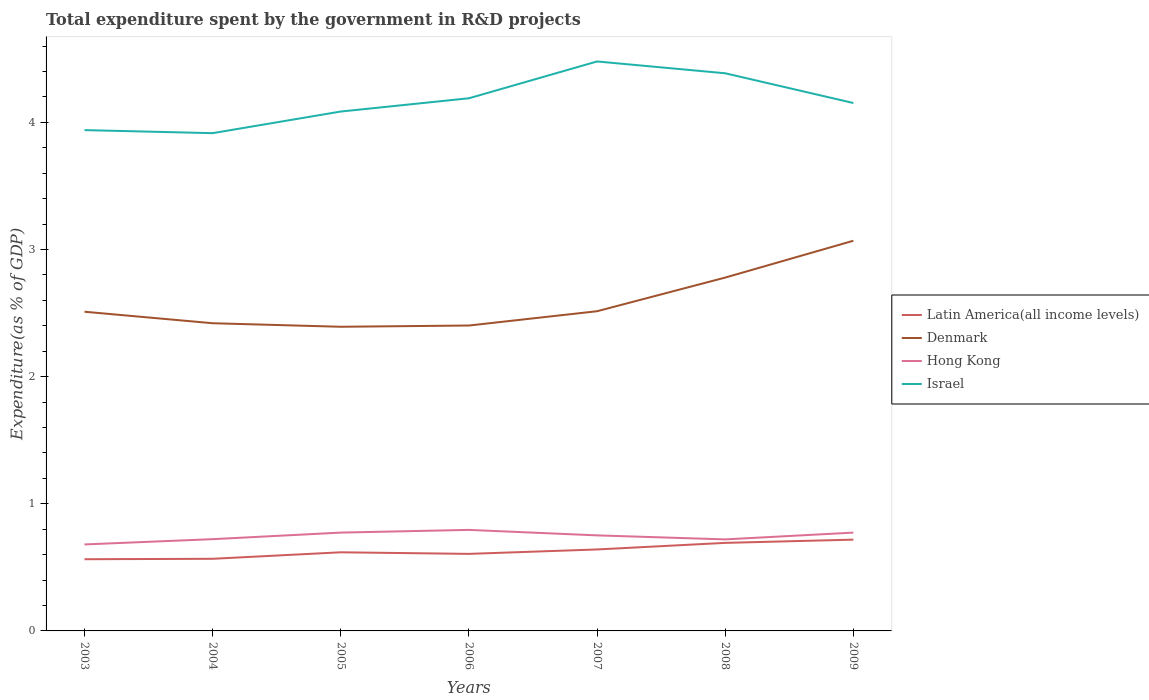How many different coloured lines are there?
Offer a very short reply. 4. Does the line corresponding to Latin America(all income levels) intersect with the line corresponding to Denmark?
Provide a short and direct response. No. Is the number of lines equal to the number of legend labels?
Give a very brief answer. Yes. Across all years, what is the maximum total expenditure spent by the government in R&D projects in Hong Kong?
Your answer should be compact. 0.68. What is the total total expenditure spent by the government in R&D projects in Israel in the graph?
Your answer should be very brief. -0.25. What is the difference between the highest and the second highest total expenditure spent by the government in R&D projects in Hong Kong?
Provide a succinct answer. 0.11. What is the difference between the highest and the lowest total expenditure spent by the government in R&D projects in Denmark?
Ensure brevity in your answer.  2. How many lines are there?
Provide a succinct answer. 4. Are the values on the major ticks of Y-axis written in scientific E-notation?
Your answer should be very brief. No. Does the graph contain any zero values?
Your response must be concise. No. Does the graph contain grids?
Your answer should be very brief. No. How many legend labels are there?
Your answer should be compact. 4. What is the title of the graph?
Offer a very short reply. Total expenditure spent by the government in R&D projects. Does "Belgium" appear as one of the legend labels in the graph?
Keep it short and to the point. No. What is the label or title of the Y-axis?
Ensure brevity in your answer.  Expenditure(as % of GDP). What is the Expenditure(as % of GDP) of Latin America(all income levels) in 2003?
Provide a succinct answer. 0.56. What is the Expenditure(as % of GDP) of Denmark in 2003?
Offer a terse response. 2.51. What is the Expenditure(as % of GDP) in Hong Kong in 2003?
Your answer should be very brief. 0.68. What is the Expenditure(as % of GDP) in Israel in 2003?
Ensure brevity in your answer.  3.94. What is the Expenditure(as % of GDP) in Latin America(all income levels) in 2004?
Offer a terse response. 0.57. What is the Expenditure(as % of GDP) in Denmark in 2004?
Make the answer very short. 2.42. What is the Expenditure(as % of GDP) in Hong Kong in 2004?
Offer a terse response. 0.72. What is the Expenditure(as % of GDP) of Israel in 2004?
Offer a terse response. 3.92. What is the Expenditure(as % of GDP) of Latin America(all income levels) in 2005?
Your answer should be compact. 0.62. What is the Expenditure(as % of GDP) of Denmark in 2005?
Provide a short and direct response. 2.39. What is the Expenditure(as % of GDP) in Hong Kong in 2005?
Your answer should be very brief. 0.77. What is the Expenditure(as % of GDP) in Israel in 2005?
Offer a very short reply. 4.09. What is the Expenditure(as % of GDP) of Latin America(all income levels) in 2006?
Provide a succinct answer. 0.61. What is the Expenditure(as % of GDP) of Denmark in 2006?
Ensure brevity in your answer.  2.4. What is the Expenditure(as % of GDP) in Hong Kong in 2006?
Keep it short and to the point. 0.79. What is the Expenditure(as % of GDP) of Israel in 2006?
Ensure brevity in your answer.  4.19. What is the Expenditure(as % of GDP) in Latin America(all income levels) in 2007?
Your answer should be very brief. 0.64. What is the Expenditure(as % of GDP) of Denmark in 2007?
Offer a very short reply. 2.51. What is the Expenditure(as % of GDP) in Hong Kong in 2007?
Provide a succinct answer. 0.75. What is the Expenditure(as % of GDP) in Israel in 2007?
Provide a succinct answer. 4.48. What is the Expenditure(as % of GDP) of Latin America(all income levels) in 2008?
Give a very brief answer. 0.69. What is the Expenditure(as % of GDP) in Denmark in 2008?
Offer a terse response. 2.78. What is the Expenditure(as % of GDP) of Hong Kong in 2008?
Keep it short and to the point. 0.72. What is the Expenditure(as % of GDP) in Israel in 2008?
Your answer should be compact. 4.39. What is the Expenditure(as % of GDP) in Latin America(all income levels) in 2009?
Make the answer very short. 0.72. What is the Expenditure(as % of GDP) in Denmark in 2009?
Ensure brevity in your answer.  3.07. What is the Expenditure(as % of GDP) in Hong Kong in 2009?
Offer a terse response. 0.77. What is the Expenditure(as % of GDP) of Israel in 2009?
Provide a succinct answer. 4.15. Across all years, what is the maximum Expenditure(as % of GDP) of Latin America(all income levels)?
Provide a succinct answer. 0.72. Across all years, what is the maximum Expenditure(as % of GDP) in Denmark?
Give a very brief answer. 3.07. Across all years, what is the maximum Expenditure(as % of GDP) of Hong Kong?
Ensure brevity in your answer.  0.79. Across all years, what is the maximum Expenditure(as % of GDP) of Israel?
Offer a very short reply. 4.48. Across all years, what is the minimum Expenditure(as % of GDP) in Latin America(all income levels)?
Your answer should be very brief. 0.56. Across all years, what is the minimum Expenditure(as % of GDP) in Denmark?
Your response must be concise. 2.39. Across all years, what is the minimum Expenditure(as % of GDP) in Hong Kong?
Ensure brevity in your answer.  0.68. Across all years, what is the minimum Expenditure(as % of GDP) of Israel?
Provide a short and direct response. 3.92. What is the total Expenditure(as % of GDP) in Latin America(all income levels) in the graph?
Give a very brief answer. 4.41. What is the total Expenditure(as % of GDP) of Denmark in the graph?
Your response must be concise. 18.09. What is the total Expenditure(as % of GDP) of Hong Kong in the graph?
Provide a succinct answer. 5.22. What is the total Expenditure(as % of GDP) in Israel in the graph?
Offer a terse response. 29.15. What is the difference between the Expenditure(as % of GDP) of Latin America(all income levels) in 2003 and that in 2004?
Keep it short and to the point. -0. What is the difference between the Expenditure(as % of GDP) of Denmark in 2003 and that in 2004?
Your answer should be compact. 0.09. What is the difference between the Expenditure(as % of GDP) of Hong Kong in 2003 and that in 2004?
Make the answer very short. -0.04. What is the difference between the Expenditure(as % of GDP) of Israel in 2003 and that in 2004?
Provide a short and direct response. 0.02. What is the difference between the Expenditure(as % of GDP) of Latin America(all income levels) in 2003 and that in 2005?
Offer a very short reply. -0.05. What is the difference between the Expenditure(as % of GDP) in Denmark in 2003 and that in 2005?
Your answer should be compact. 0.12. What is the difference between the Expenditure(as % of GDP) in Hong Kong in 2003 and that in 2005?
Your response must be concise. -0.09. What is the difference between the Expenditure(as % of GDP) of Israel in 2003 and that in 2005?
Your answer should be compact. -0.15. What is the difference between the Expenditure(as % of GDP) in Latin America(all income levels) in 2003 and that in 2006?
Offer a terse response. -0.04. What is the difference between the Expenditure(as % of GDP) of Denmark in 2003 and that in 2006?
Provide a short and direct response. 0.11. What is the difference between the Expenditure(as % of GDP) of Hong Kong in 2003 and that in 2006?
Keep it short and to the point. -0.11. What is the difference between the Expenditure(as % of GDP) in Israel in 2003 and that in 2006?
Provide a short and direct response. -0.25. What is the difference between the Expenditure(as % of GDP) of Latin America(all income levels) in 2003 and that in 2007?
Provide a short and direct response. -0.08. What is the difference between the Expenditure(as % of GDP) of Denmark in 2003 and that in 2007?
Your response must be concise. -0. What is the difference between the Expenditure(as % of GDP) of Hong Kong in 2003 and that in 2007?
Ensure brevity in your answer.  -0.07. What is the difference between the Expenditure(as % of GDP) of Israel in 2003 and that in 2007?
Give a very brief answer. -0.54. What is the difference between the Expenditure(as % of GDP) of Latin America(all income levels) in 2003 and that in 2008?
Offer a terse response. -0.13. What is the difference between the Expenditure(as % of GDP) of Denmark in 2003 and that in 2008?
Provide a short and direct response. -0.27. What is the difference between the Expenditure(as % of GDP) in Hong Kong in 2003 and that in 2008?
Make the answer very short. -0.04. What is the difference between the Expenditure(as % of GDP) of Israel in 2003 and that in 2008?
Offer a very short reply. -0.45. What is the difference between the Expenditure(as % of GDP) in Latin America(all income levels) in 2003 and that in 2009?
Offer a terse response. -0.15. What is the difference between the Expenditure(as % of GDP) of Denmark in 2003 and that in 2009?
Make the answer very short. -0.56. What is the difference between the Expenditure(as % of GDP) of Hong Kong in 2003 and that in 2009?
Ensure brevity in your answer.  -0.09. What is the difference between the Expenditure(as % of GDP) of Israel in 2003 and that in 2009?
Provide a succinct answer. -0.21. What is the difference between the Expenditure(as % of GDP) of Latin America(all income levels) in 2004 and that in 2005?
Make the answer very short. -0.05. What is the difference between the Expenditure(as % of GDP) of Denmark in 2004 and that in 2005?
Ensure brevity in your answer.  0.03. What is the difference between the Expenditure(as % of GDP) in Hong Kong in 2004 and that in 2005?
Give a very brief answer. -0.05. What is the difference between the Expenditure(as % of GDP) in Israel in 2004 and that in 2005?
Offer a terse response. -0.17. What is the difference between the Expenditure(as % of GDP) of Latin America(all income levels) in 2004 and that in 2006?
Offer a very short reply. -0.04. What is the difference between the Expenditure(as % of GDP) of Denmark in 2004 and that in 2006?
Offer a very short reply. 0.02. What is the difference between the Expenditure(as % of GDP) in Hong Kong in 2004 and that in 2006?
Make the answer very short. -0.07. What is the difference between the Expenditure(as % of GDP) in Israel in 2004 and that in 2006?
Provide a short and direct response. -0.27. What is the difference between the Expenditure(as % of GDP) of Latin America(all income levels) in 2004 and that in 2007?
Keep it short and to the point. -0.07. What is the difference between the Expenditure(as % of GDP) of Denmark in 2004 and that in 2007?
Provide a succinct answer. -0.09. What is the difference between the Expenditure(as % of GDP) in Hong Kong in 2004 and that in 2007?
Make the answer very short. -0.03. What is the difference between the Expenditure(as % of GDP) in Israel in 2004 and that in 2007?
Your answer should be very brief. -0.56. What is the difference between the Expenditure(as % of GDP) in Latin America(all income levels) in 2004 and that in 2008?
Provide a succinct answer. -0.13. What is the difference between the Expenditure(as % of GDP) in Denmark in 2004 and that in 2008?
Keep it short and to the point. -0.36. What is the difference between the Expenditure(as % of GDP) in Hong Kong in 2004 and that in 2008?
Ensure brevity in your answer.  0. What is the difference between the Expenditure(as % of GDP) in Israel in 2004 and that in 2008?
Your answer should be compact. -0.47. What is the difference between the Expenditure(as % of GDP) in Latin America(all income levels) in 2004 and that in 2009?
Make the answer very short. -0.15. What is the difference between the Expenditure(as % of GDP) of Denmark in 2004 and that in 2009?
Keep it short and to the point. -0.65. What is the difference between the Expenditure(as % of GDP) of Hong Kong in 2004 and that in 2009?
Offer a very short reply. -0.05. What is the difference between the Expenditure(as % of GDP) of Israel in 2004 and that in 2009?
Keep it short and to the point. -0.24. What is the difference between the Expenditure(as % of GDP) of Latin America(all income levels) in 2005 and that in 2006?
Ensure brevity in your answer.  0.01. What is the difference between the Expenditure(as % of GDP) in Denmark in 2005 and that in 2006?
Your response must be concise. -0.01. What is the difference between the Expenditure(as % of GDP) of Hong Kong in 2005 and that in 2006?
Give a very brief answer. -0.02. What is the difference between the Expenditure(as % of GDP) of Israel in 2005 and that in 2006?
Offer a very short reply. -0.1. What is the difference between the Expenditure(as % of GDP) in Latin America(all income levels) in 2005 and that in 2007?
Your answer should be very brief. -0.02. What is the difference between the Expenditure(as % of GDP) in Denmark in 2005 and that in 2007?
Your response must be concise. -0.12. What is the difference between the Expenditure(as % of GDP) of Hong Kong in 2005 and that in 2007?
Your answer should be very brief. 0.02. What is the difference between the Expenditure(as % of GDP) of Israel in 2005 and that in 2007?
Give a very brief answer. -0.39. What is the difference between the Expenditure(as % of GDP) in Latin America(all income levels) in 2005 and that in 2008?
Your answer should be very brief. -0.07. What is the difference between the Expenditure(as % of GDP) of Denmark in 2005 and that in 2008?
Your answer should be compact. -0.39. What is the difference between the Expenditure(as % of GDP) in Hong Kong in 2005 and that in 2008?
Your answer should be compact. 0.05. What is the difference between the Expenditure(as % of GDP) of Israel in 2005 and that in 2008?
Offer a very short reply. -0.3. What is the difference between the Expenditure(as % of GDP) of Latin America(all income levels) in 2005 and that in 2009?
Give a very brief answer. -0.1. What is the difference between the Expenditure(as % of GDP) in Denmark in 2005 and that in 2009?
Your answer should be very brief. -0.68. What is the difference between the Expenditure(as % of GDP) of Hong Kong in 2005 and that in 2009?
Your answer should be compact. 0. What is the difference between the Expenditure(as % of GDP) of Israel in 2005 and that in 2009?
Offer a very short reply. -0.07. What is the difference between the Expenditure(as % of GDP) in Latin America(all income levels) in 2006 and that in 2007?
Keep it short and to the point. -0.03. What is the difference between the Expenditure(as % of GDP) in Denmark in 2006 and that in 2007?
Ensure brevity in your answer.  -0.11. What is the difference between the Expenditure(as % of GDP) in Hong Kong in 2006 and that in 2007?
Ensure brevity in your answer.  0.04. What is the difference between the Expenditure(as % of GDP) in Israel in 2006 and that in 2007?
Keep it short and to the point. -0.29. What is the difference between the Expenditure(as % of GDP) of Latin America(all income levels) in 2006 and that in 2008?
Make the answer very short. -0.09. What is the difference between the Expenditure(as % of GDP) in Denmark in 2006 and that in 2008?
Provide a succinct answer. -0.38. What is the difference between the Expenditure(as % of GDP) of Hong Kong in 2006 and that in 2008?
Offer a very short reply. 0.07. What is the difference between the Expenditure(as % of GDP) in Israel in 2006 and that in 2008?
Make the answer very short. -0.2. What is the difference between the Expenditure(as % of GDP) in Latin America(all income levels) in 2006 and that in 2009?
Provide a succinct answer. -0.11. What is the difference between the Expenditure(as % of GDP) in Denmark in 2006 and that in 2009?
Provide a short and direct response. -0.67. What is the difference between the Expenditure(as % of GDP) in Hong Kong in 2006 and that in 2009?
Your response must be concise. 0.02. What is the difference between the Expenditure(as % of GDP) in Israel in 2006 and that in 2009?
Provide a short and direct response. 0.04. What is the difference between the Expenditure(as % of GDP) of Latin America(all income levels) in 2007 and that in 2008?
Make the answer very short. -0.05. What is the difference between the Expenditure(as % of GDP) in Denmark in 2007 and that in 2008?
Make the answer very short. -0.26. What is the difference between the Expenditure(as % of GDP) of Hong Kong in 2007 and that in 2008?
Provide a succinct answer. 0.03. What is the difference between the Expenditure(as % of GDP) of Israel in 2007 and that in 2008?
Provide a succinct answer. 0.09. What is the difference between the Expenditure(as % of GDP) in Latin America(all income levels) in 2007 and that in 2009?
Your response must be concise. -0.08. What is the difference between the Expenditure(as % of GDP) in Denmark in 2007 and that in 2009?
Your answer should be very brief. -0.55. What is the difference between the Expenditure(as % of GDP) of Hong Kong in 2007 and that in 2009?
Offer a very short reply. -0.02. What is the difference between the Expenditure(as % of GDP) in Israel in 2007 and that in 2009?
Your answer should be very brief. 0.33. What is the difference between the Expenditure(as % of GDP) in Latin America(all income levels) in 2008 and that in 2009?
Make the answer very short. -0.03. What is the difference between the Expenditure(as % of GDP) of Denmark in 2008 and that in 2009?
Offer a very short reply. -0.29. What is the difference between the Expenditure(as % of GDP) of Hong Kong in 2008 and that in 2009?
Offer a terse response. -0.05. What is the difference between the Expenditure(as % of GDP) in Israel in 2008 and that in 2009?
Ensure brevity in your answer.  0.23. What is the difference between the Expenditure(as % of GDP) in Latin America(all income levels) in 2003 and the Expenditure(as % of GDP) in Denmark in 2004?
Provide a succinct answer. -1.86. What is the difference between the Expenditure(as % of GDP) in Latin America(all income levels) in 2003 and the Expenditure(as % of GDP) in Hong Kong in 2004?
Keep it short and to the point. -0.16. What is the difference between the Expenditure(as % of GDP) of Latin America(all income levels) in 2003 and the Expenditure(as % of GDP) of Israel in 2004?
Ensure brevity in your answer.  -3.35. What is the difference between the Expenditure(as % of GDP) in Denmark in 2003 and the Expenditure(as % of GDP) in Hong Kong in 2004?
Provide a succinct answer. 1.79. What is the difference between the Expenditure(as % of GDP) in Denmark in 2003 and the Expenditure(as % of GDP) in Israel in 2004?
Your answer should be compact. -1.4. What is the difference between the Expenditure(as % of GDP) of Hong Kong in 2003 and the Expenditure(as % of GDP) of Israel in 2004?
Offer a terse response. -3.24. What is the difference between the Expenditure(as % of GDP) in Latin America(all income levels) in 2003 and the Expenditure(as % of GDP) in Denmark in 2005?
Provide a short and direct response. -1.83. What is the difference between the Expenditure(as % of GDP) of Latin America(all income levels) in 2003 and the Expenditure(as % of GDP) of Hong Kong in 2005?
Provide a succinct answer. -0.21. What is the difference between the Expenditure(as % of GDP) in Latin America(all income levels) in 2003 and the Expenditure(as % of GDP) in Israel in 2005?
Your response must be concise. -3.52. What is the difference between the Expenditure(as % of GDP) in Denmark in 2003 and the Expenditure(as % of GDP) in Hong Kong in 2005?
Offer a terse response. 1.74. What is the difference between the Expenditure(as % of GDP) in Denmark in 2003 and the Expenditure(as % of GDP) in Israel in 2005?
Your answer should be very brief. -1.57. What is the difference between the Expenditure(as % of GDP) in Hong Kong in 2003 and the Expenditure(as % of GDP) in Israel in 2005?
Your answer should be very brief. -3.41. What is the difference between the Expenditure(as % of GDP) in Latin America(all income levels) in 2003 and the Expenditure(as % of GDP) in Denmark in 2006?
Offer a very short reply. -1.84. What is the difference between the Expenditure(as % of GDP) of Latin America(all income levels) in 2003 and the Expenditure(as % of GDP) of Hong Kong in 2006?
Provide a short and direct response. -0.23. What is the difference between the Expenditure(as % of GDP) of Latin America(all income levels) in 2003 and the Expenditure(as % of GDP) of Israel in 2006?
Your response must be concise. -3.63. What is the difference between the Expenditure(as % of GDP) of Denmark in 2003 and the Expenditure(as % of GDP) of Hong Kong in 2006?
Your response must be concise. 1.72. What is the difference between the Expenditure(as % of GDP) in Denmark in 2003 and the Expenditure(as % of GDP) in Israel in 2006?
Offer a very short reply. -1.68. What is the difference between the Expenditure(as % of GDP) in Hong Kong in 2003 and the Expenditure(as % of GDP) in Israel in 2006?
Your response must be concise. -3.51. What is the difference between the Expenditure(as % of GDP) in Latin America(all income levels) in 2003 and the Expenditure(as % of GDP) in Denmark in 2007?
Ensure brevity in your answer.  -1.95. What is the difference between the Expenditure(as % of GDP) of Latin America(all income levels) in 2003 and the Expenditure(as % of GDP) of Hong Kong in 2007?
Ensure brevity in your answer.  -0.19. What is the difference between the Expenditure(as % of GDP) of Latin America(all income levels) in 2003 and the Expenditure(as % of GDP) of Israel in 2007?
Provide a succinct answer. -3.92. What is the difference between the Expenditure(as % of GDP) of Denmark in 2003 and the Expenditure(as % of GDP) of Hong Kong in 2007?
Make the answer very short. 1.76. What is the difference between the Expenditure(as % of GDP) of Denmark in 2003 and the Expenditure(as % of GDP) of Israel in 2007?
Ensure brevity in your answer.  -1.97. What is the difference between the Expenditure(as % of GDP) in Hong Kong in 2003 and the Expenditure(as % of GDP) in Israel in 2007?
Ensure brevity in your answer.  -3.8. What is the difference between the Expenditure(as % of GDP) in Latin America(all income levels) in 2003 and the Expenditure(as % of GDP) in Denmark in 2008?
Your response must be concise. -2.22. What is the difference between the Expenditure(as % of GDP) in Latin America(all income levels) in 2003 and the Expenditure(as % of GDP) in Hong Kong in 2008?
Your answer should be compact. -0.16. What is the difference between the Expenditure(as % of GDP) of Latin America(all income levels) in 2003 and the Expenditure(as % of GDP) of Israel in 2008?
Ensure brevity in your answer.  -3.82. What is the difference between the Expenditure(as % of GDP) in Denmark in 2003 and the Expenditure(as % of GDP) in Hong Kong in 2008?
Keep it short and to the point. 1.79. What is the difference between the Expenditure(as % of GDP) of Denmark in 2003 and the Expenditure(as % of GDP) of Israel in 2008?
Provide a succinct answer. -1.88. What is the difference between the Expenditure(as % of GDP) of Hong Kong in 2003 and the Expenditure(as % of GDP) of Israel in 2008?
Ensure brevity in your answer.  -3.71. What is the difference between the Expenditure(as % of GDP) in Latin America(all income levels) in 2003 and the Expenditure(as % of GDP) in Denmark in 2009?
Give a very brief answer. -2.51. What is the difference between the Expenditure(as % of GDP) in Latin America(all income levels) in 2003 and the Expenditure(as % of GDP) in Hong Kong in 2009?
Keep it short and to the point. -0.21. What is the difference between the Expenditure(as % of GDP) in Latin America(all income levels) in 2003 and the Expenditure(as % of GDP) in Israel in 2009?
Give a very brief answer. -3.59. What is the difference between the Expenditure(as % of GDP) of Denmark in 2003 and the Expenditure(as % of GDP) of Hong Kong in 2009?
Provide a short and direct response. 1.74. What is the difference between the Expenditure(as % of GDP) in Denmark in 2003 and the Expenditure(as % of GDP) in Israel in 2009?
Provide a short and direct response. -1.64. What is the difference between the Expenditure(as % of GDP) in Hong Kong in 2003 and the Expenditure(as % of GDP) in Israel in 2009?
Provide a succinct answer. -3.47. What is the difference between the Expenditure(as % of GDP) in Latin America(all income levels) in 2004 and the Expenditure(as % of GDP) in Denmark in 2005?
Make the answer very short. -1.83. What is the difference between the Expenditure(as % of GDP) in Latin America(all income levels) in 2004 and the Expenditure(as % of GDP) in Hong Kong in 2005?
Provide a succinct answer. -0.21. What is the difference between the Expenditure(as % of GDP) of Latin America(all income levels) in 2004 and the Expenditure(as % of GDP) of Israel in 2005?
Give a very brief answer. -3.52. What is the difference between the Expenditure(as % of GDP) in Denmark in 2004 and the Expenditure(as % of GDP) in Hong Kong in 2005?
Give a very brief answer. 1.65. What is the difference between the Expenditure(as % of GDP) of Denmark in 2004 and the Expenditure(as % of GDP) of Israel in 2005?
Your answer should be very brief. -1.67. What is the difference between the Expenditure(as % of GDP) in Hong Kong in 2004 and the Expenditure(as % of GDP) in Israel in 2005?
Give a very brief answer. -3.36. What is the difference between the Expenditure(as % of GDP) of Latin America(all income levels) in 2004 and the Expenditure(as % of GDP) of Denmark in 2006?
Your response must be concise. -1.83. What is the difference between the Expenditure(as % of GDP) in Latin America(all income levels) in 2004 and the Expenditure(as % of GDP) in Hong Kong in 2006?
Ensure brevity in your answer.  -0.23. What is the difference between the Expenditure(as % of GDP) in Latin America(all income levels) in 2004 and the Expenditure(as % of GDP) in Israel in 2006?
Offer a very short reply. -3.62. What is the difference between the Expenditure(as % of GDP) of Denmark in 2004 and the Expenditure(as % of GDP) of Hong Kong in 2006?
Provide a short and direct response. 1.63. What is the difference between the Expenditure(as % of GDP) in Denmark in 2004 and the Expenditure(as % of GDP) in Israel in 2006?
Make the answer very short. -1.77. What is the difference between the Expenditure(as % of GDP) of Hong Kong in 2004 and the Expenditure(as % of GDP) of Israel in 2006?
Ensure brevity in your answer.  -3.47. What is the difference between the Expenditure(as % of GDP) of Latin America(all income levels) in 2004 and the Expenditure(as % of GDP) of Denmark in 2007?
Offer a terse response. -1.95. What is the difference between the Expenditure(as % of GDP) of Latin America(all income levels) in 2004 and the Expenditure(as % of GDP) of Hong Kong in 2007?
Give a very brief answer. -0.18. What is the difference between the Expenditure(as % of GDP) in Latin America(all income levels) in 2004 and the Expenditure(as % of GDP) in Israel in 2007?
Your response must be concise. -3.91. What is the difference between the Expenditure(as % of GDP) in Denmark in 2004 and the Expenditure(as % of GDP) in Hong Kong in 2007?
Make the answer very short. 1.67. What is the difference between the Expenditure(as % of GDP) of Denmark in 2004 and the Expenditure(as % of GDP) of Israel in 2007?
Your answer should be very brief. -2.06. What is the difference between the Expenditure(as % of GDP) in Hong Kong in 2004 and the Expenditure(as % of GDP) in Israel in 2007?
Keep it short and to the point. -3.76. What is the difference between the Expenditure(as % of GDP) in Latin America(all income levels) in 2004 and the Expenditure(as % of GDP) in Denmark in 2008?
Your answer should be compact. -2.21. What is the difference between the Expenditure(as % of GDP) in Latin America(all income levels) in 2004 and the Expenditure(as % of GDP) in Hong Kong in 2008?
Offer a terse response. -0.15. What is the difference between the Expenditure(as % of GDP) of Latin America(all income levels) in 2004 and the Expenditure(as % of GDP) of Israel in 2008?
Offer a terse response. -3.82. What is the difference between the Expenditure(as % of GDP) in Denmark in 2004 and the Expenditure(as % of GDP) in Hong Kong in 2008?
Provide a succinct answer. 1.7. What is the difference between the Expenditure(as % of GDP) of Denmark in 2004 and the Expenditure(as % of GDP) of Israel in 2008?
Keep it short and to the point. -1.97. What is the difference between the Expenditure(as % of GDP) in Hong Kong in 2004 and the Expenditure(as % of GDP) in Israel in 2008?
Offer a very short reply. -3.66. What is the difference between the Expenditure(as % of GDP) of Latin America(all income levels) in 2004 and the Expenditure(as % of GDP) of Denmark in 2009?
Give a very brief answer. -2.5. What is the difference between the Expenditure(as % of GDP) in Latin America(all income levels) in 2004 and the Expenditure(as % of GDP) in Hong Kong in 2009?
Give a very brief answer. -0.21. What is the difference between the Expenditure(as % of GDP) of Latin America(all income levels) in 2004 and the Expenditure(as % of GDP) of Israel in 2009?
Provide a succinct answer. -3.59. What is the difference between the Expenditure(as % of GDP) in Denmark in 2004 and the Expenditure(as % of GDP) in Hong Kong in 2009?
Offer a very short reply. 1.65. What is the difference between the Expenditure(as % of GDP) in Denmark in 2004 and the Expenditure(as % of GDP) in Israel in 2009?
Provide a succinct answer. -1.73. What is the difference between the Expenditure(as % of GDP) in Hong Kong in 2004 and the Expenditure(as % of GDP) in Israel in 2009?
Your answer should be compact. -3.43. What is the difference between the Expenditure(as % of GDP) in Latin America(all income levels) in 2005 and the Expenditure(as % of GDP) in Denmark in 2006?
Ensure brevity in your answer.  -1.78. What is the difference between the Expenditure(as % of GDP) in Latin America(all income levels) in 2005 and the Expenditure(as % of GDP) in Hong Kong in 2006?
Make the answer very short. -0.18. What is the difference between the Expenditure(as % of GDP) in Latin America(all income levels) in 2005 and the Expenditure(as % of GDP) in Israel in 2006?
Give a very brief answer. -3.57. What is the difference between the Expenditure(as % of GDP) of Denmark in 2005 and the Expenditure(as % of GDP) of Hong Kong in 2006?
Offer a terse response. 1.6. What is the difference between the Expenditure(as % of GDP) in Denmark in 2005 and the Expenditure(as % of GDP) in Israel in 2006?
Offer a terse response. -1.8. What is the difference between the Expenditure(as % of GDP) of Hong Kong in 2005 and the Expenditure(as % of GDP) of Israel in 2006?
Provide a short and direct response. -3.42. What is the difference between the Expenditure(as % of GDP) in Latin America(all income levels) in 2005 and the Expenditure(as % of GDP) in Denmark in 2007?
Offer a terse response. -1.9. What is the difference between the Expenditure(as % of GDP) in Latin America(all income levels) in 2005 and the Expenditure(as % of GDP) in Hong Kong in 2007?
Your answer should be compact. -0.13. What is the difference between the Expenditure(as % of GDP) in Latin America(all income levels) in 2005 and the Expenditure(as % of GDP) in Israel in 2007?
Your response must be concise. -3.86. What is the difference between the Expenditure(as % of GDP) in Denmark in 2005 and the Expenditure(as % of GDP) in Hong Kong in 2007?
Offer a very short reply. 1.64. What is the difference between the Expenditure(as % of GDP) of Denmark in 2005 and the Expenditure(as % of GDP) of Israel in 2007?
Provide a short and direct response. -2.09. What is the difference between the Expenditure(as % of GDP) of Hong Kong in 2005 and the Expenditure(as % of GDP) of Israel in 2007?
Ensure brevity in your answer.  -3.71. What is the difference between the Expenditure(as % of GDP) of Latin America(all income levels) in 2005 and the Expenditure(as % of GDP) of Denmark in 2008?
Your response must be concise. -2.16. What is the difference between the Expenditure(as % of GDP) in Latin America(all income levels) in 2005 and the Expenditure(as % of GDP) in Hong Kong in 2008?
Ensure brevity in your answer.  -0.1. What is the difference between the Expenditure(as % of GDP) of Latin America(all income levels) in 2005 and the Expenditure(as % of GDP) of Israel in 2008?
Keep it short and to the point. -3.77. What is the difference between the Expenditure(as % of GDP) in Denmark in 2005 and the Expenditure(as % of GDP) in Hong Kong in 2008?
Your response must be concise. 1.67. What is the difference between the Expenditure(as % of GDP) of Denmark in 2005 and the Expenditure(as % of GDP) of Israel in 2008?
Your answer should be very brief. -1.99. What is the difference between the Expenditure(as % of GDP) of Hong Kong in 2005 and the Expenditure(as % of GDP) of Israel in 2008?
Your response must be concise. -3.61. What is the difference between the Expenditure(as % of GDP) in Latin America(all income levels) in 2005 and the Expenditure(as % of GDP) in Denmark in 2009?
Offer a very short reply. -2.45. What is the difference between the Expenditure(as % of GDP) in Latin America(all income levels) in 2005 and the Expenditure(as % of GDP) in Hong Kong in 2009?
Provide a short and direct response. -0.15. What is the difference between the Expenditure(as % of GDP) in Latin America(all income levels) in 2005 and the Expenditure(as % of GDP) in Israel in 2009?
Make the answer very short. -3.53. What is the difference between the Expenditure(as % of GDP) of Denmark in 2005 and the Expenditure(as % of GDP) of Hong Kong in 2009?
Keep it short and to the point. 1.62. What is the difference between the Expenditure(as % of GDP) in Denmark in 2005 and the Expenditure(as % of GDP) in Israel in 2009?
Offer a very short reply. -1.76. What is the difference between the Expenditure(as % of GDP) of Hong Kong in 2005 and the Expenditure(as % of GDP) of Israel in 2009?
Offer a very short reply. -3.38. What is the difference between the Expenditure(as % of GDP) of Latin America(all income levels) in 2006 and the Expenditure(as % of GDP) of Denmark in 2007?
Your answer should be very brief. -1.91. What is the difference between the Expenditure(as % of GDP) of Latin America(all income levels) in 2006 and the Expenditure(as % of GDP) of Hong Kong in 2007?
Ensure brevity in your answer.  -0.15. What is the difference between the Expenditure(as % of GDP) of Latin America(all income levels) in 2006 and the Expenditure(as % of GDP) of Israel in 2007?
Ensure brevity in your answer.  -3.87. What is the difference between the Expenditure(as % of GDP) of Denmark in 2006 and the Expenditure(as % of GDP) of Hong Kong in 2007?
Offer a very short reply. 1.65. What is the difference between the Expenditure(as % of GDP) of Denmark in 2006 and the Expenditure(as % of GDP) of Israel in 2007?
Ensure brevity in your answer.  -2.08. What is the difference between the Expenditure(as % of GDP) in Hong Kong in 2006 and the Expenditure(as % of GDP) in Israel in 2007?
Provide a short and direct response. -3.68. What is the difference between the Expenditure(as % of GDP) of Latin America(all income levels) in 2006 and the Expenditure(as % of GDP) of Denmark in 2008?
Provide a succinct answer. -2.17. What is the difference between the Expenditure(as % of GDP) in Latin America(all income levels) in 2006 and the Expenditure(as % of GDP) in Hong Kong in 2008?
Your response must be concise. -0.11. What is the difference between the Expenditure(as % of GDP) of Latin America(all income levels) in 2006 and the Expenditure(as % of GDP) of Israel in 2008?
Offer a terse response. -3.78. What is the difference between the Expenditure(as % of GDP) of Denmark in 2006 and the Expenditure(as % of GDP) of Hong Kong in 2008?
Your answer should be very brief. 1.68. What is the difference between the Expenditure(as % of GDP) of Denmark in 2006 and the Expenditure(as % of GDP) of Israel in 2008?
Provide a short and direct response. -1.98. What is the difference between the Expenditure(as % of GDP) of Hong Kong in 2006 and the Expenditure(as % of GDP) of Israel in 2008?
Offer a terse response. -3.59. What is the difference between the Expenditure(as % of GDP) in Latin America(all income levels) in 2006 and the Expenditure(as % of GDP) in Denmark in 2009?
Ensure brevity in your answer.  -2.46. What is the difference between the Expenditure(as % of GDP) in Latin America(all income levels) in 2006 and the Expenditure(as % of GDP) in Hong Kong in 2009?
Ensure brevity in your answer.  -0.17. What is the difference between the Expenditure(as % of GDP) of Latin America(all income levels) in 2006 and the Expenditure(as % of GDP) of Israel in 2009?
Keep it short and to the point. -3.55. What is the difference between the Expenditure(as % of GDP) of Denmark in 2006 and the Expenditure(as % of GDP) of Hong Kong in 2009?
Your answer should be compact. 1.63. What is the difference between the Expenditure(as % of GDP) in Denmark in 2006 and the Expenditure(as % of GDP) in Israel in 2009?
Your response must be concise. -1.75. What is the difference between the Expenditure(as % of GDP) of Hong Kong in 2006 and the Expenditure(as % of GDP) of Israel in 2009?
Your response must be concise. -3.36. What is the difference between the Expenditure(as % of GDP) of Latin America(all income levels) in 2007 and the Expenditure(as % of GDP) of Denmark in 2008?
Ensure brevity in your answer.  -2.14. What is the difference between the Expenditure(as % of GDP) of Latin America(all income levels) in 2007 and the Expenditure(as % of GDP) of Hong Kong in 2008?
Offer a very short reply. -0.08. What is the difference between the Expenditure(as % of GDP) of Latin America(all income levels) in 2007 and the Expenditure(as % of GDP) of Israel in 2008?
Offer a terse response. -3.75. What is the difference between the Expenditure(as % of GDP) of Denmark in 2007 and the Expenditure(as % of GDP) of Hong Kong in 2008?
Ensure brevity in your answer.  1.79. What is the difference between the Expenditure(as % of GDP) in Denmark in 2007 and the Expenditure(as % of GDP) in Israel in 2008?
Offer a very short reply. -1.87. What is the difference between the Expenditure(as % of GDP) of Hong Kong in 2007 and the Expenditure(as % of GDP) of Israel in 2008?
Provide a succinct answer. -3.63. What is the difference between the Expenditure(as % of GDP) of Latin America(all income levels) in 2007 and the Expenditure(as % of GDP) of Denmark in 2009?
Provide a short and direct response. -2.43. What is the difference between the Expenditure(as % of GDP) in Latin America(all income levels) in 2007 and the Expenditure(as % of GDP) in Hong Kong in 2009?
Make the answer very short. -0.13. What is the difference between the Expenditure(as % of GDP) of Latin America(all income levels) in 2007 and the Expenditure(as % of GDP) of Israel in 2009?
Offer a very short reply. -3.51. What is the difference between the Expenditure(as % of GDP) in Denmark in 2007 and the Expenditure(as % of GDP) in Hong Kong in 2009?
Give a very brief answer. 1.74. What is the difference between the Expenditure(as % of GDP) of Denmark in 2007 and the Expenditure(as % of GDP) of Israel in 2009?
Your response must be concise. -1.64. What is the difference between the Expenditure(as % of GDP) in Hong Kong in 2007 and the Expenditure(as % of GDP) in Israel in 2009?
Ensure brevity in your answer.  -3.4. What is the difference between the Expenditure(as % of GDP) in Latin America(all income levels) in 2008 and the Expenditure(as % of GDP) in Denmark in 2009?
Provide a short and direct response. -2.38. What is the difference between the Expenditure(as % of GDP) of Latin America(all income levels) in 2008 and the Expenditure(as % of GDP) of Hong Kong in 2009?
Provide a succinct answer. -0.08. What is the difference between the Expenditure(as % of GDP) in Latin America(all income levels) in 2008 and the Expenditure(as % of GDP) in Israel in 2009?
Ensure brevity in your answer.  -3.46. What is the difference between the Expenditure(as % of GDP) of Denmark in 2008 and the Expenditure(as % of GDP) of Hong Kong in 2009?
Your answer should be compact. 2.01. What is the difference between the Expenditure(as % of GDP) of Denmark in 2008 and the Expenditure(as % of GDP) of Israel in 2009?
Provide a succinct answer. -1.37. What is the difference between the Expenditure(as % of GDP) of Hong Kong in 2008 and the Expenditure(as % of GDP) of Israel in 2009?
Give a very brief answer. -3.43. What is the average Expenditure(as % of GDP) in Latin America(all income levels) per year?
Make the answer very short. 0.63. What is the average Expenditure(as % of GDP) of Denmark per year?
Your answer should be compact. 2.58. What is the average Expenditure(as % of GDP) of Hong Kong per year?
Your response must be concise. 0.74. What is the average Expenditure(as % of GDP) in Israel per year?
Provide a short and direct response. 4.16. In the year 2003, what is the difference between the Expenditure(as % of GDP) in Latin America(all income levels) and Expenditure(as % of GDP) in Denmark?
Your answer should be compact. -1.95. In the year 2003, what is the difference between the Expenditure(as % of GDP) of Latin America(all income levels) and Expenditure(as % of GDP) of Hong Kong?
Offer a very short reply. -0.12. In the year 2003, what is the difference between the Expenditure(as % of GDP) in Latin America(all income levels) and Expenditure(as % of GDP) in Israel?
Provide a succinct answer. -3.38. In the year 2003, what is the difference between the Expenditure(as % of GDP) of Denmark and Expenditure(as % of GDP) of Hong Kong?
Your response must be concise. 1.83. In the year 2003, what is the difference between the Expenditure(as % of GDP) of Denmark and Expenditure(as % of GDP) of Israel?
Your response must be concise. -1.43. In the year 2003, what is the difference between the Expenditure(as % of GDP) in Hong Kong and Expenditure(as % of GDP) in Israel?
Provide a short and direct response. -3.26. In the year 2004, what is the difference between the Expenditure(as % of GDP) of Latin America(all income levels) and Expenditure(as % of GDP) of Denmark?
Give a very brief answer. -1.85. In the year 2004, what is the difference between the Expenditure(as % of GDP) in Latin America(all income levels) and Expenditure(as % of GDP) in Hong Kong?
Give a very brief answer. -0.15. In the year 2004, what is the difference between the Expenditure(as % of GDP) of Latin America(all income levels) and Expenditure(as % of GDP) of Israel?
Offer a terse response. -3.35. In the year 2004, what is the difference between the Expenditure(as % of GDP) of Denmark and Expenditure(as % of GDP) of Hong Kong?
Provide a short and direct response. 1.7. In the year 2004, what is the difference between the Expenditure(as % of GDP) of Denmark and Expenditure(as % of GDP) of Israel?
Your answer should be very brief. -1.5. In the year 2004, what is the difference between the Expenditure(as % of GDP) in Hong Kong and Expenditure(as % of GDP) in Israel?
Make the answer very short. -3.19. In the year 2005, what is the difference between the Expenditure(as % of GDP) in Latin America(all income levels) and Expenditure(as % of GDP) in Denmark?
Your answer should be very brief. -1.77. In the year 2005, what is the difference between the Expenditure(as % of GDP) in Latin America(all income levels) and Expenditure(as % of GDP) in Hong Kong?
Offer a terse response. -0.15. In the year 2005, what is the difference between the Expenditure(as % of GDP) of Latin America(all income levels) and Expenditure(as % of GDP) of Israel?
Provide a succinct answer. -3.47. In the year 2005, what is the difference between the Expenditure(as % of GDP) in Denmark and Expenditure(as % of GDP) in Hong Kong?
Give a very brief answer. 1.62. In the year 2005, what is the difference between the Expenditure(as % of GDP) in Denmark and Expenditure(as % of GDP) in Israel?
Provide a short and direct response. -1.69. In the year 2005, what is the difference between the Expenditure(as % of GDP) of Hong Kong and Expenditure(as % of GDP) of Israel?
Offer a very short reply. -3.31. In the year 2006, what is the difference between the Expenditure(as % of GDP) in Latin America(all income levels) and Expenditure(as % of GDP) in Denmark?
Make the answer very short. -1.8. In the year 2006, what is the difference between the Expenditure(as % of GDP) in Latin America(all income levels) and Expenditure(as % of GDP) in Hong Kong?
Keep it short and to the point. -0.19. In the year 2006, what is the difference between the Expenditure(as % of GDP) in Latin America(all income levels) and Expenditure(as % of GDP) in Israel?
Give a very brief answer. -3.58. In the year 2006, what is the difference between the Expenditure(as % of GDP) in Denmark and Expenditure(as % of GDP) in Hong Kong?
Give a very brief answer. 1.61. In the year 2006, what is the difference between the Expenditure(as % of GDP) in Denmark and Expenditure(as % of GDP) in Israel?
Your answer should be very brief. -1.79. In the year 2006, what is the difference between the Expenditure(as % of GDP) of Hong Kong and Expenditure(as % of GDP) of Israel?
Your answer should be compact. -3.4. In the year 2007, what is the difference between the Expenditure(as % of GDP) of Latin America(all income levels) and Expenditure(as % of GDP) of Denmark?
Give a very brief answer. -1.87. In the year 2007, what is the difference between the Expenditure(as % of GDP) of Latin America(all income levels) and Expenditure(as % of GDP) of Hong Kong?
Ensure brevity in your answer.  -0.11. In the year 2007, what is the difference between the Expenditure(as % of GDP) of Latin America(all income levels) and Expenditure(as % of GDP) of Israel?
Make the answer very short. -3.84. In the year 2007, what is the difference between the Expenditure(as % of GDP) in Denmark and Expenditure(as % of GDP) in Hong Kong?
Your answer should be compact. 1.76. In the year 2007, what is the difference between the Expenditure(as % of GDP) in Denmark and Expenditure(as % of GDP) in Israel?
Provide a succinct answer. -1.96. In the year 2007, what is the difference between the Expenditure(as % of GDP) in Hong Kong and Expenditure(as % of GDP) in Israel?
Offer a terse response. -3.73. In the year 2008, what is the difference between the Expenditure(as % of GDP) in Latin America(all income levels) and Expenditure(as % of GDP) in Denmark?
Make the answer very short. -2.09. In the year 2008, what is the difference between the Expenditure(as % of GDP) in Latin America(all income levels) and Expenditure(as % of GDP) in Hong Kong?
Keep it short and to the point. -0.03. In the year 2008, what is the difference between the Expenditure(as % of GDP) in Latin America(all income levels) and Expenditure(as % of GDP) in Israel?
Ensure brevity in your answer.  -3.69. In the year 2008, what is the difference between the Expenditure(as % of GDP) in Denmark and Expenditure(as % of GDP) in Hong Kong?
Ensure brevity in your answer.  2.06. In the year 2008, what is the difference between the Expenditure(as % of GDP) of Denmark and Expenditure(as % of GDP) of Israel?
Make the answer very short. -1.61. In the year 2008, what is the difference between the Expenditure(as % of GDP) of Hong Kong and Expenditure(as % of GDP) of Israel?
Your answer should be very brief. -3.67. In the year 2009, what is the difference between the Expenditure(as % of GDP) in Latin America(all income levels) and Expenditure(as % of GDP) in Denmark?
Your answer should be very brief. -2.35. In the year 2009, what is the difference between the Expenditure(as % of GDP) in Latin America(all income levels) and Expenditure(as % of GDP) in Hong Kong?
Your answer should be compact. -0.06. In the year 2009, what is the difference between the Expenditure(as % of GDP) in Latin America(all income levels) and Expenditure(as % of GDP) in Israel?
Ensure brevity in your answer.  -3.43. In the year 2009, what is the difference between the Expenditure(as % of GDP) in Denmark and Expenditure(as % of GDP) in Hong Kong?
Keep it short and to the point. 2.3. In the year 2009, what is the difference between the Expenditure(as % of GDP) of Denmark and Expenditure(as % of GDP) of Israel?
Provide a succinct answer. -1.08. In the year 2009, what is the difference between the Expenditure(as % of GDP) in Hong Kong and Expenditure(as % of GDP) in Israel?
Offer a very short reply. -3.38. What is the ratio of the Expenditure(as % of GDP) of Denmark in 2003 to that in 2004?
Your response must be concise. 1.04. What is the ratio of the Expenditure(as % of GDP) in Hong Kong in 2003 to that in 2004?
Your response must be concise. 0.94. What is the ratio of the Expenditure(as % of GDP) of Latin America(all income levels) in 2003 to that in 2005?
Your answer should be very brief. 0.91. What is the ratio of the Expenditure(as % of GDP) in Denmark in 2003 to that in 2005?
Make the answer very short. 1.05. What is the ratio of the Expenditure(as % of GDP) of Hong Kong in 2003 to that in 2005?
Offer a very short reply. 0.88. What is the ratio of the Expenditure(as % of GDP) of Israel in 2003 to that in 2005?
Offer a very short reply. 0.96. What is the ratio of the Expenditure(as % of GDP) of Latin America(all income levels) in 2003 to that in 2006?
Your response must be concise. 0.93. What is the ratio of the Expenditure(as % of GDP) of Denmark in 2003 to that in 2006?
Give a very brief answer. 1.05. What is the ratio of the Expenditure(as % of GDP) of Hong Kong in 2003 to that in 2006?
Provide a succinct answer. 0.86. What is the ratio of the Expenditure(as % of GDP) of Israel in 2003 to that in 2006?
Your answer should be compact. 0.94. What is the ratio of the Expenditure(as % of GDP) in Latin America(all income levels) in 2003 to that in 2007?
Your answer should be very brief. 0.88. What is the ratio of the Expenditure(as % of GDP) of Hong Kong in 2003 to that in 2007?
Your answer should be compact. 0.91. What is the ratio of the Expenditure(as % of GDP) in Israel in 2003 to that in 2007?
Offer a very short reply. 0.88. What is the ratio of the Expenditure(as % of GDP) in Latin America(all income levels) in 2003 to that in 2008?
Provide a succinct answer. 0.81. What is the ratio of the Expenditure(as % of GDP) of Denmark in 2003 to that in 2008?
Ensure brevity in your answer.  0.9. What is the ratio of the Expenditure(as % of GDP) of Hong Kong in 2003 to that in 2008?
Your response must be concise. 0.94. What is the ratio of the Expenditure(as % of GDP) in Israel in 2003 to that in 2008?
Keep it short and to the point. 0.9. What is the ratio of the Expenditure(as % of GDP) in Latin America(all income levels) in 2003 to that in 2009?
Make the answer very short. 0.79. What is the ratio of the Expenditure(as % of GDP) of Denmark in 2003 to that in 2009?
Keep it short and to the point. 0.82. What is the ratio of the Expenditure(as % of GDP) in Hong Kong in 2003 to that in 2009?
Keep it short and to the point. 0.88. What is the ratio of the Expenditure(as % of GDP) in Israel in 2003 to that in 2009?
Offer a very short reply. 0.95. What is the ratio of the Expenditure(as % of GDP) in Latin America(all income levels) in 2004 to that in 2005?
Your answer should be compact. 0.92. What is the ratio of the Expenditure(as % of GDP) of Denmark in 2004 to that in 2005?
Provide a short and direct response. 1.01. What is the ratio of the Expenditure(as % of GDP) of Hong Kong in 2004 to that in 2005?
Your response must be concise. 0.93. What is the ratio of the Expenditure(as % of GDP) in Israel in 2004 to that in 2005?
Make the answer very short. 0.96. What is the ratio of the Expenditure(as % of GDP) in Latin America(all income levels) in 2004 to that in 2006?
Your answer should be very brief. 0.94. What is the ratio of the Expenditure(as % of GDP) of Denmark in 2004 to that in 2006?
Make the answer very short. 1.01. What is the ratio of the Expenditure(as % of GDP) of Hong Kong in 2004 to that in 2006?
Ensure brevity in your answer.  0.91. What is the ratio of the Expenditure(as % of GDP) in Israel in 2004 to that in 2006?
Offer a terse response. 0.93. What is the ratio of the Expenditure(as % of GDP) of Latin America(all income levels) in 2004 to that in 2007?
Your response must be concise. 0.89. What is the ratio of the Expenditure(as % of GDP) of Denmark in 2004 to that in 2007?
Your answer should be very brief. 0.96. What is the ratio of the Expenditure(as % of GDP) in Hong Kong in 2004 to that in 2007?
Ensure brevity in your answer.  0.96. What is the ratio of the Expenditure(as % of GDP) in Israel in 2004 to that in 2007?
Your answer should be compact. 0.87. What is the ratio of the Expenditure(as % of GDP) in Latin America(all income levels) in 2004 to that in 2008?
Offer a terse response. 0.82. What is the ratio of the Expenditure(as % of GDP) of Denmark in 2004 to that in 2008?
Make the answer very short. 0.87. What is the ratio of the Expenditure(as % of GDP) of Israel in 2004 to that in 2008?
Offer a very short reply. 0.89. What is the ratio of the Expenditure(as % of GDP) of Latin America(all income levels) in 2004 to that in 2009?
Your answer should be compact. 0.79. What is the ratio of the Expenditure(as % of GDP) in Denmark in 2004 to that in 2009?
Your answer should be compact. 0.79. What is the ratio of the Expenditure(as % of GDP) of Hong Kong in 2004 to that in 2009?
Make the answer very short. 0.93. What is the ratio of the Expenditure(as % of GDP) in Israel in 2004 to that in 2009?
Ensure brevity in your answer.  0.94. What is the ratio of the Expenditure(as % of GDP) in Latin America(all income levels) in 2005 to that in 2006?
Provide a succinct answer. 1.02. What is the ratio of the Expenditure(as % of GDP) of Denmark in 2005 to that in 2006?
Make the answer very short. 1. What is the ratio of the Expenditure(as % of GDP) of Hong Kong in 2005 to that in 2006?
Your answer should be very brief. 0.97. What is the ratio of the Expenditure(as % of GDP) in Israel in 2005 to that in 2006?
Keep it short and to the point. 0.98. What is the ratio of the Expenditure(as % of GDP) in Latin America(all income levels) in 2005 to that in 2007?
Ensure brevity in your answer.  0.97. What is the ratio of the Expenditure(as % of GDP) in Denmark in 2005 to that in 2007?
Your answer should be very brief. 0.95. What is the ratio of the Expenditure(as % of GDP) in Israel in 2005 to that in 2007?
Ensure brevity in your answer.  0.91. What is the ratio of the Expenditure(as % of GDP) in Latin America(all income levels) in 2005 to that in 2008?
Your response must be concise. 0.89. What is the ratio of the Expenditure(as % of GDP) in Denmark in 2005 to that in 2008?
Offer a terse response. 0.86. What is the ratio of the Expenditure(as % of GDP) in Hong Kong in 2005 to that in 2008?
Keep it short and to the point. 1.07. What is the ratio of the Expenditure(as % of GDP) in Israel in 2005 to that in 2008?
Ensure brevity in your answer.  0.93. What is the ratio of the Expenditure(as % of GDP) of Latin America(all income levels) in 2005 to that in 2009?
Offer a very short reply. 0.86. What is the ratio of the Expenditure(as % of GDP) in Denmark in 2005 to that in 2009?
Keep it short and to the point. 0.78. What is the ratio of the Expenditure(as % of GDP) in Israel in 2005 to that in 2009?
Offer a terse response. 0.98. What is the ratio of the Expenditure(as % of GDP) in Latin America(all income levels) in 2006 to that in 2007?
Offer a terse response. 0.95. What is the ratio of the Expenditure(as % of GDP) in Denmark in 2006 to that in 2007?
Offer a terse response. 0.96. What is the ratio of the Expenditure(as % of GDP) of Hong Kong in 2006 to that in 2007?
Provide a succinct answer. 1.06. What is the ratio of the Expenditure(as % of GDP) in Israel in 2006 to that in 2007?
Offer a terse response. 0.94. What is the ratio of the Expenditure(as % of GDP) in Latin America(all income levels) in 2006 to that in 2008?
Offer a very short reply. 0.88. What is the ratio of the Expenditure(as % of GDP) in Denmark in 2006 to that in 2008?
Provide a succinct answer. 0.86. What is the ratio of the Expenditure(as % of GDP) in Hong Kong in 2006 to that in 2008?
Ensure brevity in your answer.  1.1. What is the ratio of the Expenditure(as % of GDP) in Israel in 2006 to that in 2008?
Offer a terse response. 0.96. What is the ratio of the Expenditure(as % of GDP) of Latin America(all income levels) in 2006 to that in 2009?
Your answer should be very brief. 0.84. What is the ratio of the Expenditure(as % of GDP) in Denmark in 2006 to that in 2009?
Keep it short and to the point. 0.78. What is the ratio of the Expenditure(as % of GDP) of Hong Kong in 2006 to that in 2009?
Provide a succinct answer. 1.03. What is the ratio of the Expenditure(as % of GDP) in Israel in 2006 to that in 2009?
Offer a terse response. 1.01. What is the ratio of the Expenditure(as % of GDP) of Latin America(all income levels) in 2007 to that in 2008?
Keep it short and to the point. 0.93. What is the ratio of the Expenditure(as % of GDP) of Denmark in 2007 to that in 2008?
Give a very brief answer. 0.9. What is the ratio of the Expenditure(as % of GDP) of Hong Kong in 2007 to that in 2008?
Provide a short and direct response. 1.04. What is the ratio of the Expenditure(as % of GDP) in Israel in 2007 to that in 2008?
Give a very brief answer. 1.02. What is the ratio of the Expenditure(as % of GDP) of Latin America(all income levels) in 2007 to that in 2009?
Your answer should be very brief. 0.89. What is the ratio of the Expenditure(as % of GDP) in Denmark in 2007 to that in 2009?
Ensure brevity in your answer.  0.82. What is the ratio of the Expenditure(as % of GDP) in Hong Kong in 2007 to that in 2009?
Provide a short and direct response. 0.97. What is the ratio of the Expenditure(as % of GDP) of Israel in 2007 to that in 2009?
Your response must be concise. 1.08. What is the ratio of the Expenditure(as % of GDP) in Latin America(all income levels) in 2008 to that in 2009?
Your response must be concise. 0.96. What is the ratio of the Expenditure(as % of GDP) of Denmark in 2008 to that in 2009?
Make the answer very short. 0.91. What is the ratio of the Expenditure(as % of GDP) in Hong Kong in 2008 to that in 2009?
Your response must be concise. 0.93. What is the ratio of the Expenditure(as % of GDP) of Israel in 2008 to that in 2009?
Ensure brevity in your answer.  1.06. What is the difference between the highest and the second highest Expenditure(as % of GDP) of Latin America(all income levels)?
Ensure brevity in your answer.  0.03. What is the difference between the highest and the second highest Expenditure(as % of GDP) in Denmark?
Ensure brevity in your answer.  0.29. What is the difference between the highest and the second highest Expenditure(as % of GDP) in Hong Kong?
Offer a terse response. 0.02. What is the difference between the highest and the second highest Expenditure(as % of GDP) of Israel?
Your response must be concise. 0.09. What is the difference between the highest and the lowest Expenditure(as % of GDP) of Latin America(all income levels)?
Provide a succinct answer. 0.15. What is the difference between the highest and the lowest Expenditure(as % of GDP) in Denmark?
Your response must be concise. 0.68. What is the difference between the highest and the lowest Expenditure(as % of GDP) in Hong Kong?
Your answer should be compact. 0.11. What is the difference between the highest and the lowest Expenditure(as % of GDP) of Israel?
Offer a very short reply. 0.56. 